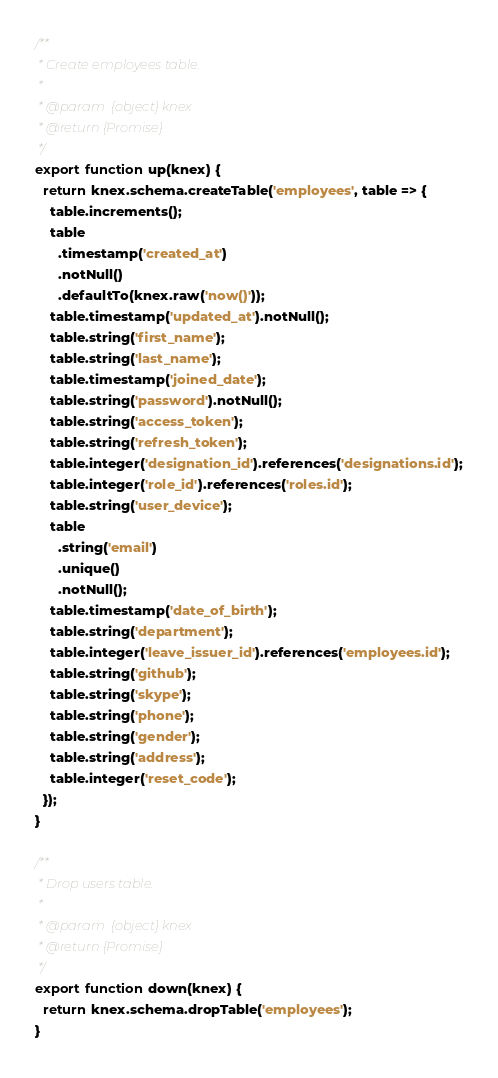<code> <loc_0><loc_0><loc_500><loc_500><_JavaScript_>/**
 * Create employees table.
 *
 * @param  {object} knex
 * @return {Promise}
 */
export function up(knex) {
  return knex.schema.createTable('employees', table => {
    table.increments();
    table
      .timestamp('created_at')
      .notNull()
      .defaultTo(knex.raw('now()'));
    table.timestamp('updated_at').notNull();
    table.string('first_name');
    table.string('last_name');
    table.timestamp('joined_date');
    table.string('password').notNull();
    table.string('access_token');
    table.string('refresh_token');
    table.integer('designation_id').references('designations.id');
    table.integer('role_id').references('roles.id');
    table.string('user_device');
    table
      .string('email')
      .unique()
      .notNull();
    table.timestamp('date_of_birth');
    table.string('department');
    table.integer('leave_issuer_id').references('employees.id');
    table.string('github');
    table.string('skype');
    table.string('phone');
    table.string('gender');
    table.string('address');
    table.integer('reset_code');
  });
}

/**
 * Drop users table.
 *
 * @param  {object} knex
 * @return {Promise}
 */
export function down(knex) {
  return knex.schema.dropTable('employees');
}
</code> 